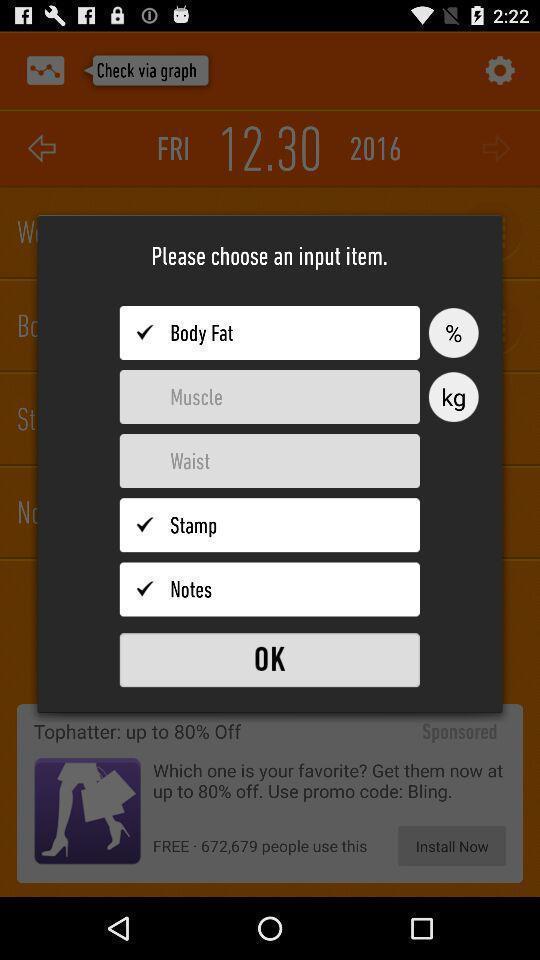Provide a detailed account of this screenshot. Pop-up with options on a fitness app. 